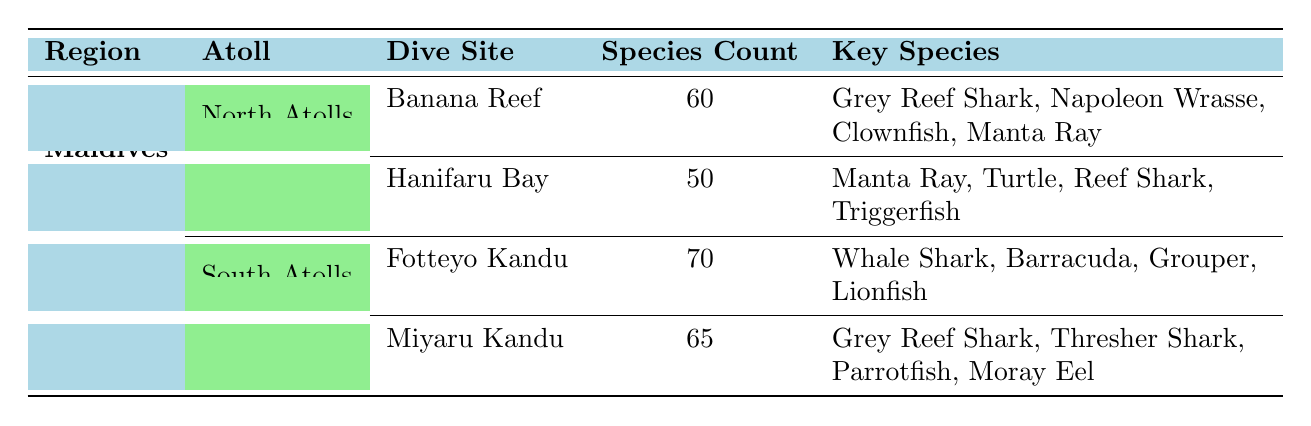What is the dive site in the South Atolls with the highest species count? The table lists the species counts for each dive site. Fotteyo Kandu has a species count of 70, which is higher than Miyaru Kandu's count of 65. Therefore, the dive site in the South Atolls with the highest species count is Fotteyo Kandu.
Answer: Fotteyo Kandu How many key species are found at Banana Reef? The table shows that Banana Reef has a list of key species, which includes Grey Reef Shark, Napoleon Wrasse, Clownfish, and Manta Ray. Counting these, we find there are four key species at this dive site.
Answer: 4 Which atoll has a dive site with 65 species? According to the table, Miyaru Kandu, located in the South Atolls, has a species count of 65. Therefore, the atoll with a dive site featuring 65 species is the South Atolls.
Answer: South Atolls Is Manta Ray considered a key species at Hanifaru Bay? The table indicates that Manta Ray is listed as a key species for Hanifaru Bay. Thus, it is true that Manta Ray is a key species at this dive site.
Answer: Yes What is the total species count for all dive sites in the North Atolls? The species counts for the North Atolls dive sites are 60 for Banana Reef and 50 for Hanifaru Bay. Adding these counts together, we have 60 + 50 = 110. Therefore, the total species count for all dive sites in the North Atolls is 110.
Answer: 110 Which dive site has the least amount of key species? Banana Reef has 4 key species, while Hanifaru Bay has 4 key species as well. Both are higher than the minimum found at other sites. In the South Atolls, both Fotteyo Kandu and Miyaru Kandu have 4 and 4 key species, respectively. Here, the key species count is even higher, making it 4 among all. Thus, there’s no dive site with fewer than 4 key species.
Answer: None What is the average species count of dive sites in the South Atolls? Fotteyo Kandu has a species count of 70 and Miyaru Kandu has 65. We sum these values to get 70 + 65 = 135 and then divide by 2, leading to an average of 135 / 2 = 67.5. Therefore, the average species count in the South Atolls is 67.5.
Answer: 67.5 Which key species are found at Fotteyo Kandu? The table lists the key species at Fotteyo Kandu: Whale Shark, Barracuda, Grouper, and Lionfish. This means that these four species are found at that specific dive site.
Answer: Whale Shark, Barracuda, Grouper, Lionfish Is there a dive site in the Maldives without sharks? Checking the dive sites listed, both Hanifaru Bay and Banana Reef feature reef sharks as key species. The other sites, Fotteyo Kandu and Miyaru Kandu, also mention sharks. Thus, there is no dive site without sharks, making it false.
Answer: No 